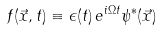<formula> <loc_0><loc_0><loc_500><loc_500>f ( \vec { x } , t ) \equiv \epsilon ( t ) \, e ^ { i \Omega t } \psi ^ { \ast } ( \vec { x } )</formula> 